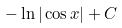Convert formula to latex. <formula><loc_0><loc_0><loc_500><loc_500>- \ln | \cos x | + C</formula> 